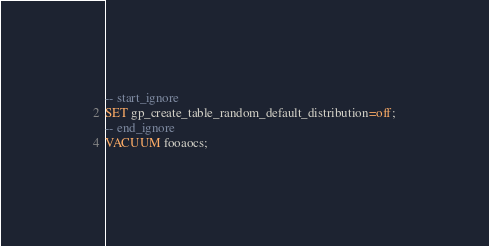<code> <loc_0><loc_0><loc_500><loc_500><_SQL_>-- start_ignore
SET gp_create_table_random_default_distribution=off;
-- end_ignore
VACUUM fooaocs;
</code> 